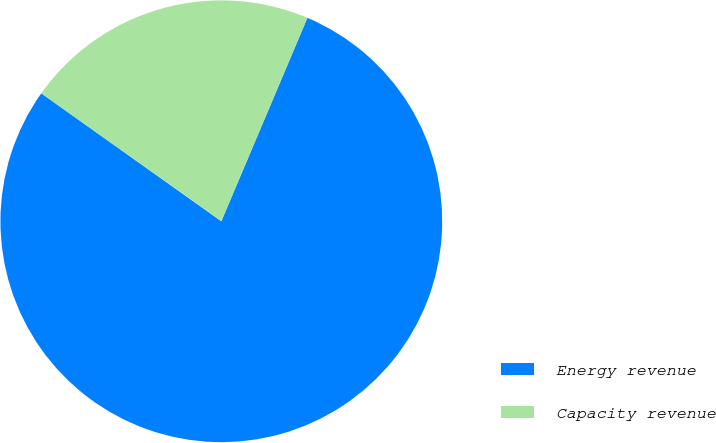Convert chart to OTSL. <chart><loc_0><loc_0><loc_500><loc_500><pie_chart><fcel>Energy revenue<fcel>Capacity revenue<nl><fcel>78.46%<fcel>21.54%<nl></chart> 